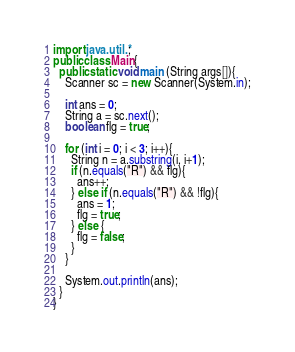Convert code to text. <code><loc_0><loc_0><loc_500><loc_500><_Java_>import java.util.*;
public class Main{
  public static void main (String args[]){
    Scanner sc = new Scanner(System.in);
    
    int ans = 0;
    String a = sc.next();
    boolean flg = true;
    
    for (int i = 0; i < 3; i++){
      String n = a.substring(i, i+1);
      if (n.equals("R") && flg){
        ans++;
      } else if (n.equals("R") && !flg){
        ans = 1;
        flg = true;
      } else {
        flg = false;
      }
    }
    
    System.out.println(ans);
  }
}</code> 